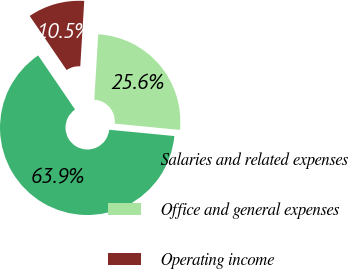Convert chart to OTSL. <chart><loc_0><loc_0><loc_500><loc_500><pie_chart><fcel>Salaries and related expenses<fcel>Office and general expenses<fcel>Operating income<nl><fcel>63.94%<fcel>25.57%<fcel>10.49%<nl></chart> 